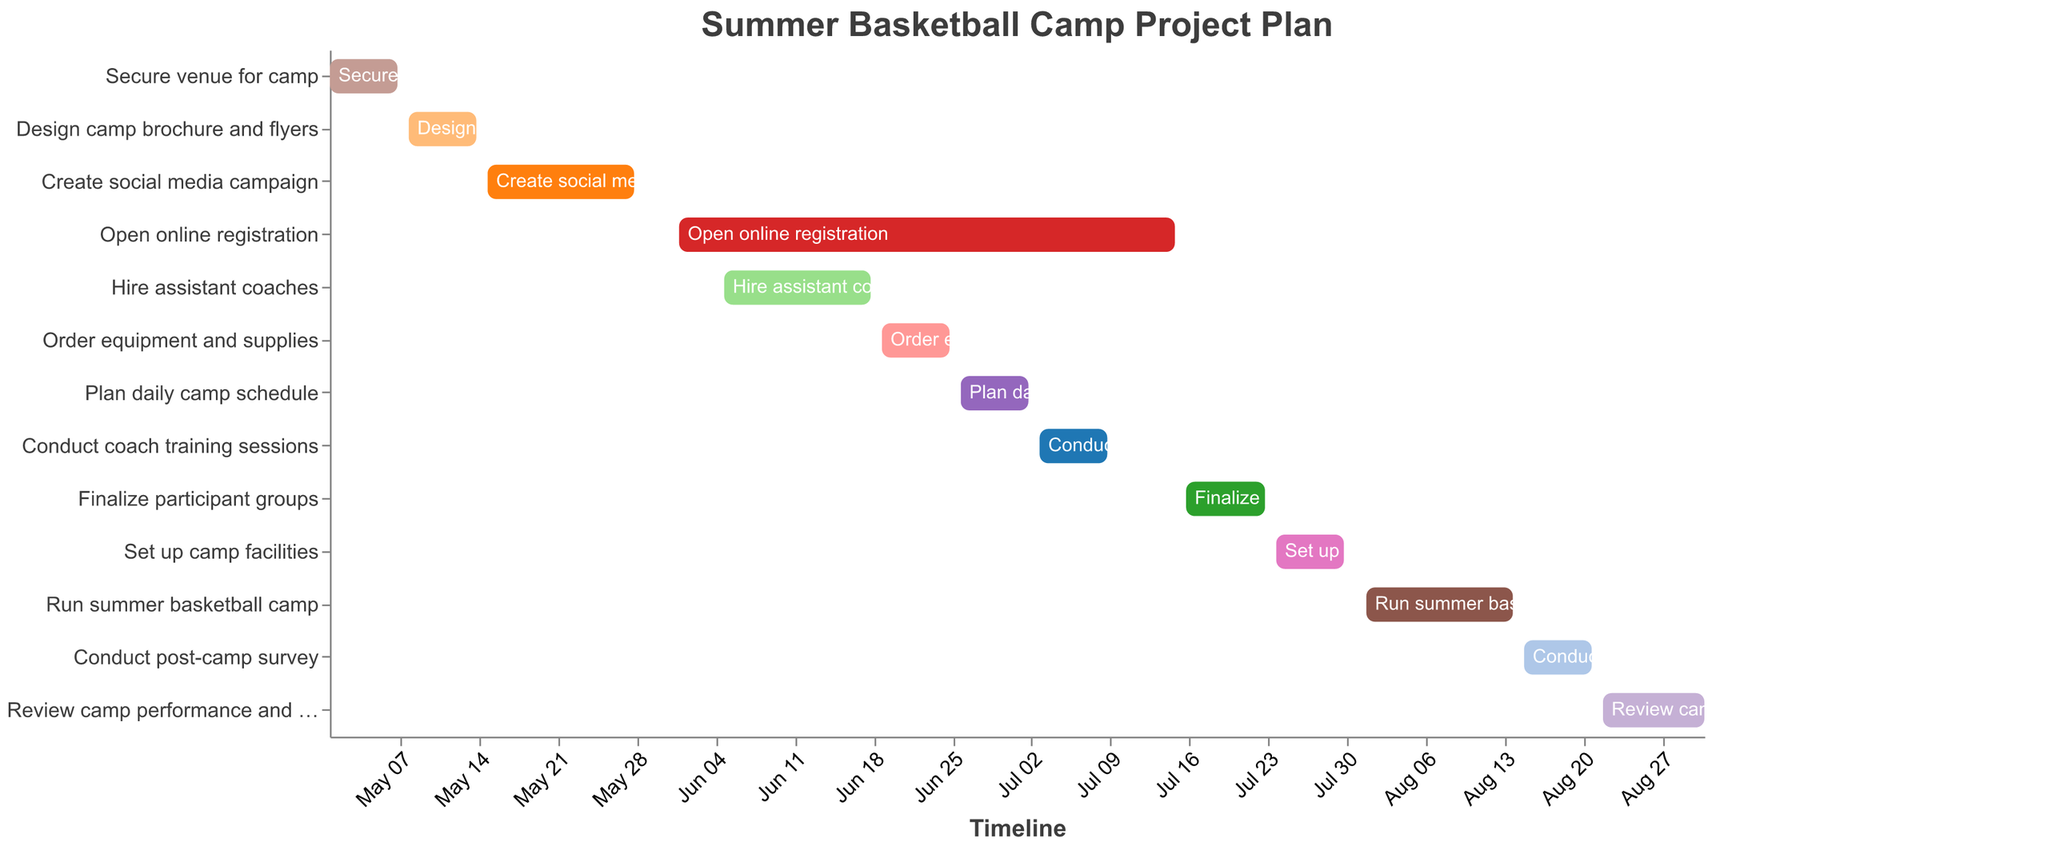What is the title of the figure? The title of the figure is displayed at the top and usually summarizes the content of the chart. Here, it is given as "Summer Basketball Camp Project Plan."
Answer: Summer Basketball Camp Project Plan Which task has the longest duration? To determine the longest duration, look for the task that spans the greatest number of days on the timeline. "Open online registration" spans from June 1 to July 15, making it the longest at 45 days.
Answer: Open online registration How many tasks are there in total? Count the number of distinct tasks listed vertically on the y-axis. There are 13 tasks listed from "Secure venue for camp" to "Review camp performance and plan improvements."
Answer: 13 Which task ends right before the "Run summer basketball camp" starts? Identify the task that ends on July 30, which is just before the "Run summer basketball camp" starts on August 1. "Set up camp facilities" ends on July 30.
Answer: Set up camp facilities When does the "Conduct post-camp survey" task take place? Look for the "Conduct post-camp survey" task on the y-axis and note its start and end dates on the timeline. It starts on August 15 and ends on August 21.
Answer: August 15 to August 21 Compare the duration of "Create social media campaign" and "Hire assistant coaches." Which one takes longer? Find the duration for both tasks and compare them. "Create social media campaign" lasts 14 days (May 15 to May 28), and "Hire assistant coaches" also lasts 14 days (June 5 to June 18). Both tasks have the same duration.
Answer: Both have the same duration What is the average duration of all tasks? Add up the duration of all tasks and divide by the number of tasks: (7+7+14+45+14+7+7+7+8+7+14+7+10)/13 = 180/13 ≈ 13.85 days.
Answer: Approximately 13.85 days Which tasks run simultaneously at any point in June? Examine the timeline in June to identify overlapping tasks. "Open online registration" (June 1 - July 15) overlaps with "Hire assistant coaches" (June 5 - June 18), "Order equipment and supplies" (June 19 - June 25), and "Plan daily camp schedule" (June 26 - July 2).
Answer: Open online registration, Hire assistant coaches, Order equipment and supplies, Plan daily camp schedule When is the "Order equipment and supplies" task scheduled? Look at the y-axis for "Order equipment and supplies" and identify its start and end dates on the timeline: June 19 to June 25.
Answer: June 19 to June 25 Which tasks need to be completed before the camp can be run? Identify tasks that end before August 1 since the camp runs from August 1 to August 14. All tasks from "Secure venue for camp" to "Set up camp facilities" must be completed before the camp starts.
Answer: Secure venue for camp, Design camp brochure and flyers, Create social media campaign, Open online registration, Hire assistant coaches, Order equipment and supplies, Plan daily camp schedule, Conduct coach training sessions, Finalize participant groups, Set up camp facilities 